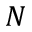<formula> <loc_0><loc_0><loc_500><loc_500>N</formula> 